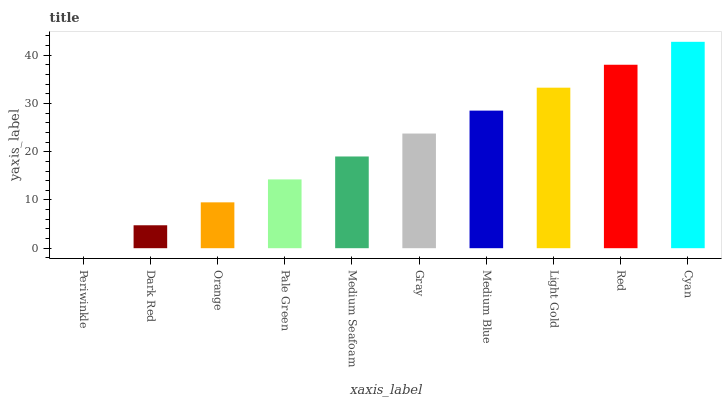Is Periwinkle the minimum?
Answer yes or no. Yes. Is Cyan the maximum?
Answer yes or no. Yes. Is Dark Red the minimum?
Answer yes or no. No. Is Dark Red the maximum?
Answer yes or no. No. Is Dark Red greater than Periwinkle?
Answer yes or no. Yes. Is Periwinkle less than Dark Red?
Answer yes or no. Yes. Is Periwinkle greater than Dark Red?
Answer yes or no. No. Is Dark Red less than Periwinkle?
Answer yes or no. No. Is Gray the high median?
Answer yes or no. Yes. Is Medium Seafoam the low median?
Answer yes or no. Yes. Is Pale Green the high median?
Answer yes or no. No. Is Medium Blue the low median?
Answer yes or no. No. 